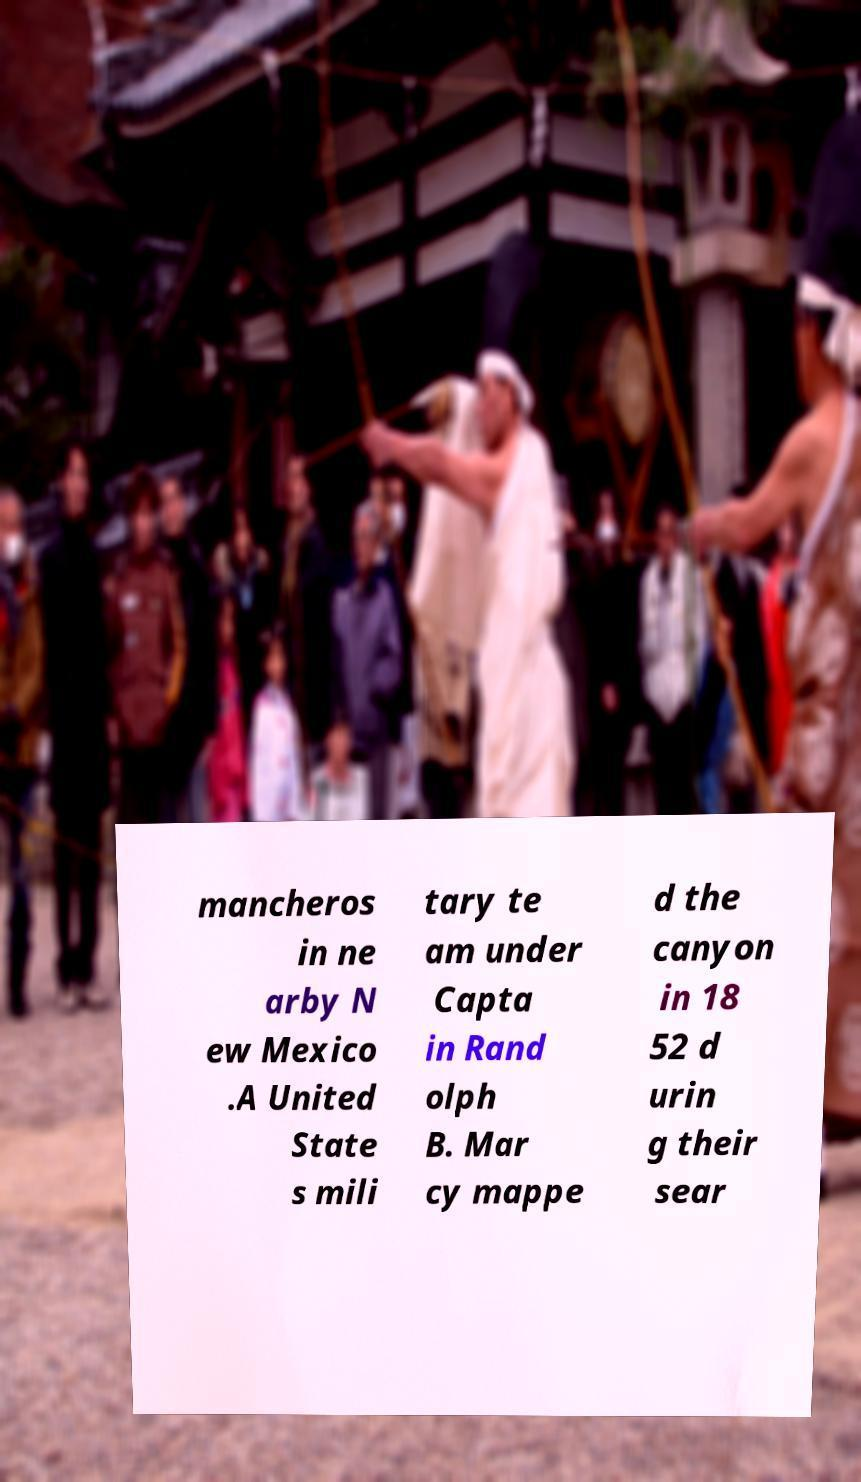What messages or text are displayed in this image? I need them in a readable, typed format. mancheros in ne arby N ew Mexico .A United State s mili tary te am under Capta in Rand olph B. Mar cy mappe d the canyon in 18 52 d urin g their sear 